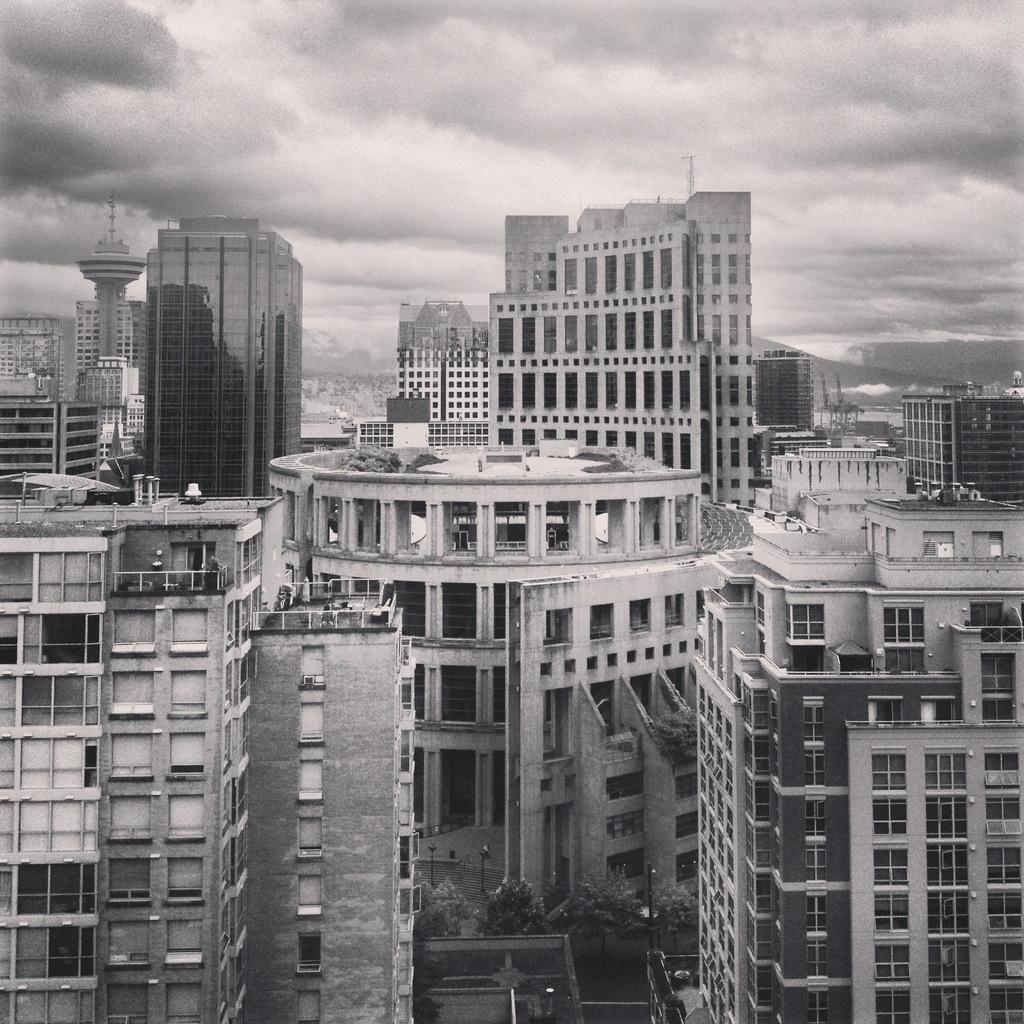What type of structures can be seen in the image? There are many buildings in the image, including skyscrapers. What is visible at the top of the image? Clouds are visible at the top of the image. What else can be seen in the sky in the image? The sky is visible in the image. What type of canvas is being used to paint the buildings in the image? There is no canvas present in the image, as it is a photograph or digital representation of the buildings. 